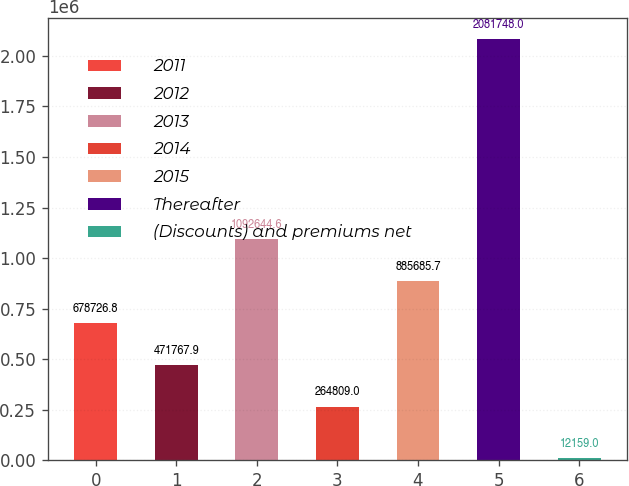<chart> <loc_0><loc_0><loc_500><loc_500><bar_chart><fcel>2011<fcel>2012<fcel>2013<fcel>2014<fcel>2015<fcel>Thereafter<fcel>(Discounts) and premiums net<nl><fcel>678727<fcel>471768<fcel>1.09264e+06<fcel>264809<fcel>885686<fcel>2.08175e+06<fcel>12159<nl></chart> 